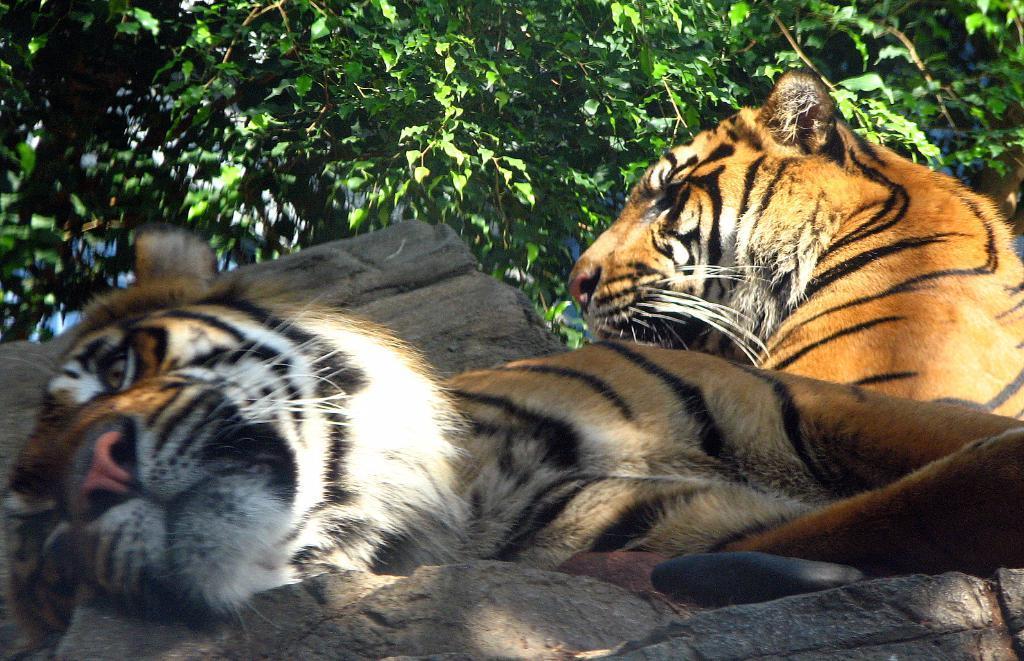How would you summarize this image in a sentence or two? Here we can see tigers. In the background there are trees. 